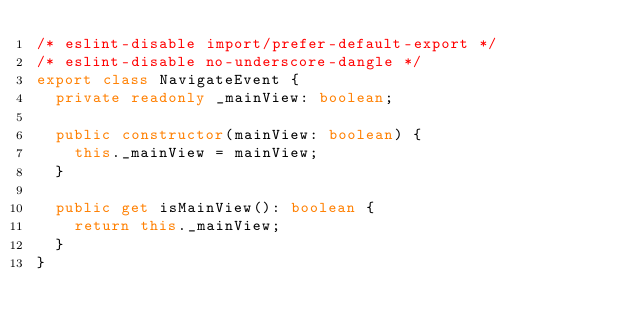Convert code to text. <code><loc_0><loc_0><loc_500><loc_500><_TypeScript_>/* eslint-disable import/prefer-default-export */
/* eslint-disable no-underscore-dangle */
export class NavigateEvent {
  private readonly _mainView: boolean;

  public constructor(mainView: boolean) {
    this._mainView = mainView;
  }

  public get isMainView(): boolean {
    return this._mainView;
  }
}
</code> 